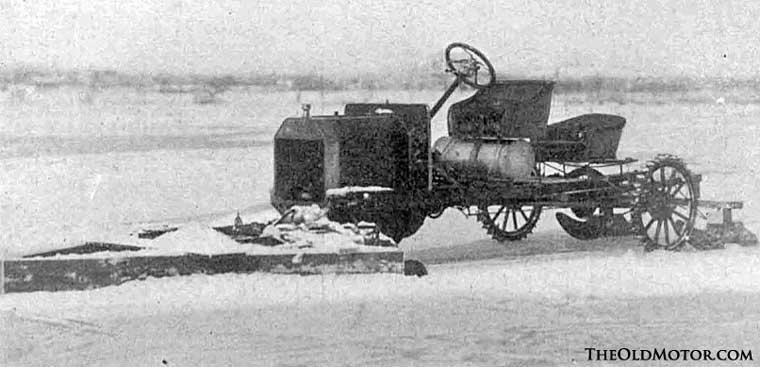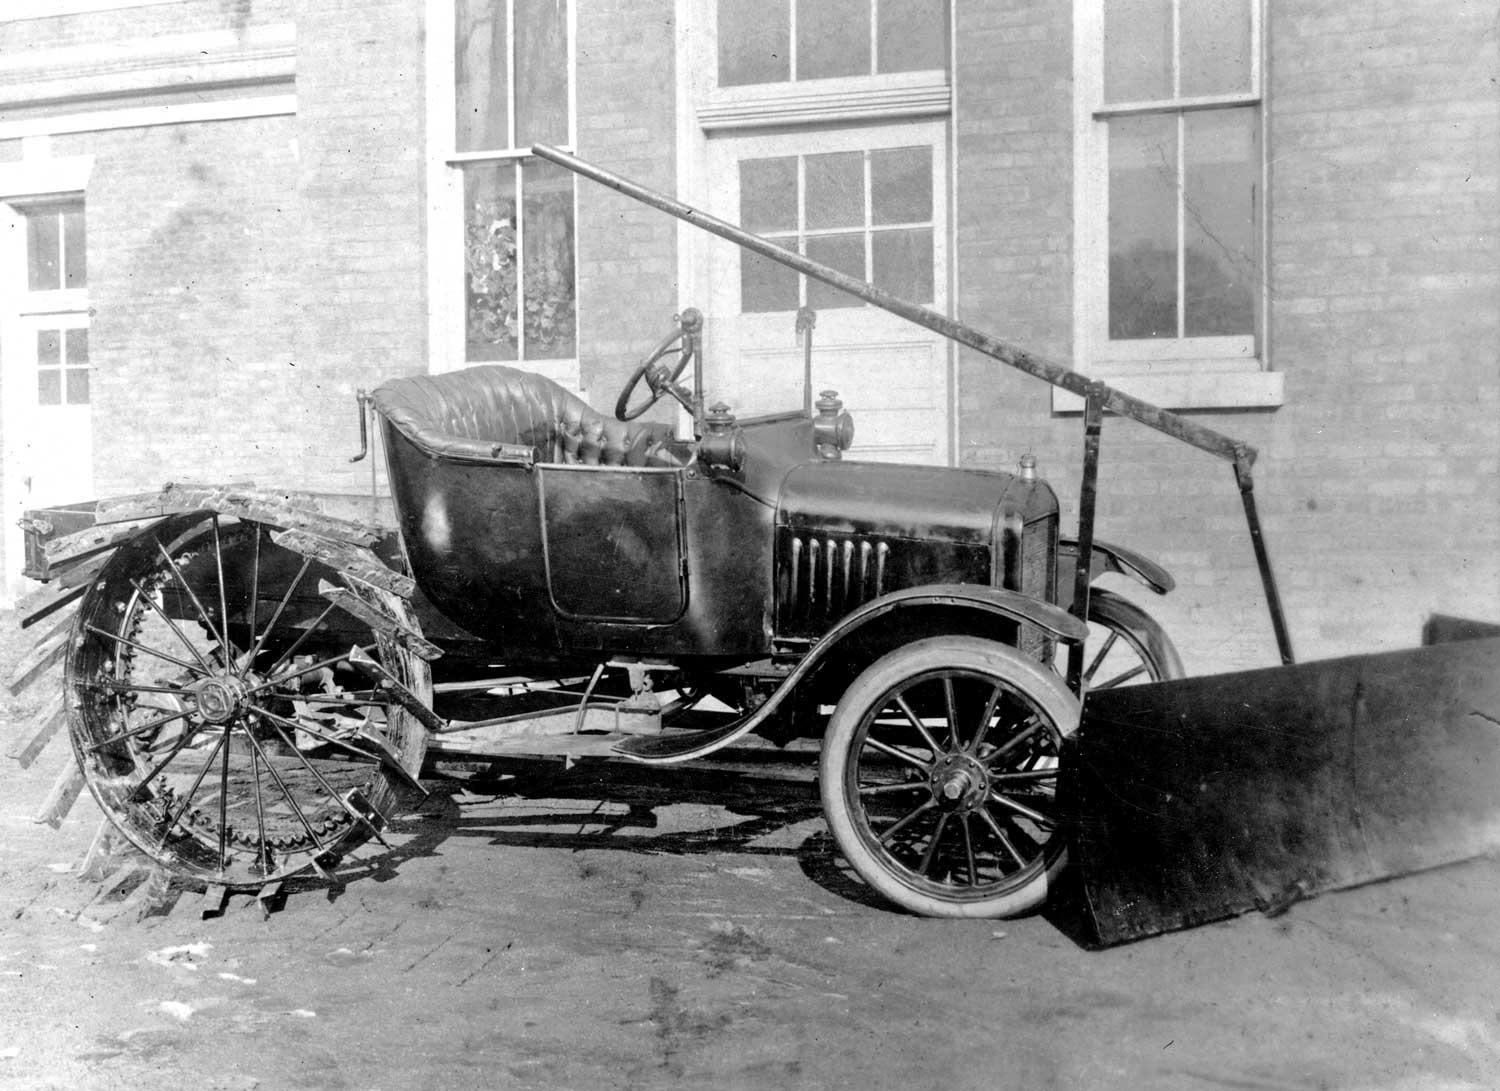The first image is the image on the left, the second image is the image on the right. Examine the images to the left and right. Is the description "Both images in the pair are in black and white." accurate? Answer yes or no. Yes. The first image is the image on the left, the second image is the image on the right. Evaluate the accuracy of this statement regarding the images: "In at least one image there is a single motorized snow plow going left.". Is it true? Answer yes or no. Yes. 